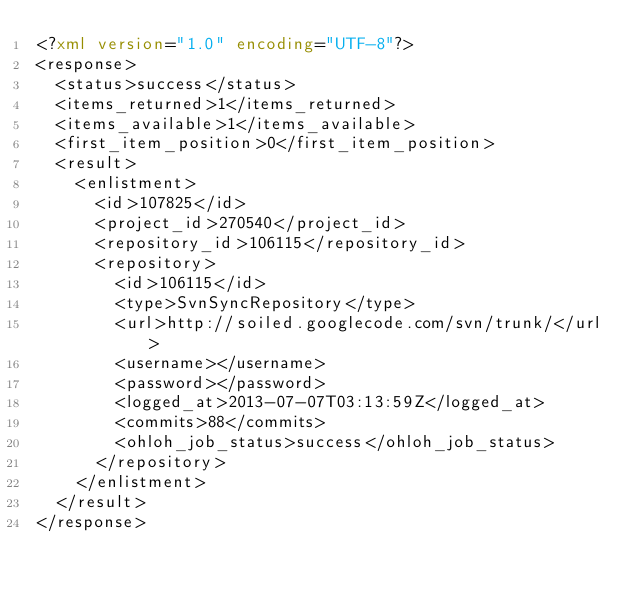Convert code to text. <code><loc_0><loc_0><loc_500><loc_500><_XML_><?xml version="1.0" encoding="UTF-8"?>
<response>
  <status>success</status>
  <items_returned>1</items_returned>
  <items_available>1</items_available>
  <first_item_position>0</first_item_position>
  <result>
    <enlistment>
      <id>107825</id>
      <project_id>270540</project_id>
      <repository_id>106115</repository_id>
      <repository>
        <id>106115</id>
        <type>SvnSyncRepository</type>
        <url>http://soiled.googlecode.com/svn/trunk/</url>
        <username></username>
        <password></password>
        <logged_at>2013-07-07T03:13:59Z</logged_at>
        <commits>88</commits>
        <ohloh_job_status>success</ohloh_job_status>
      </repository>
    </enlistment>
  </result>
</response>
</code> 